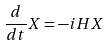Convert formula to latex. <formula><loc_0><loc_0><loc_500><loc_500>\frac { d } { d t } X = - i H X</formula> 